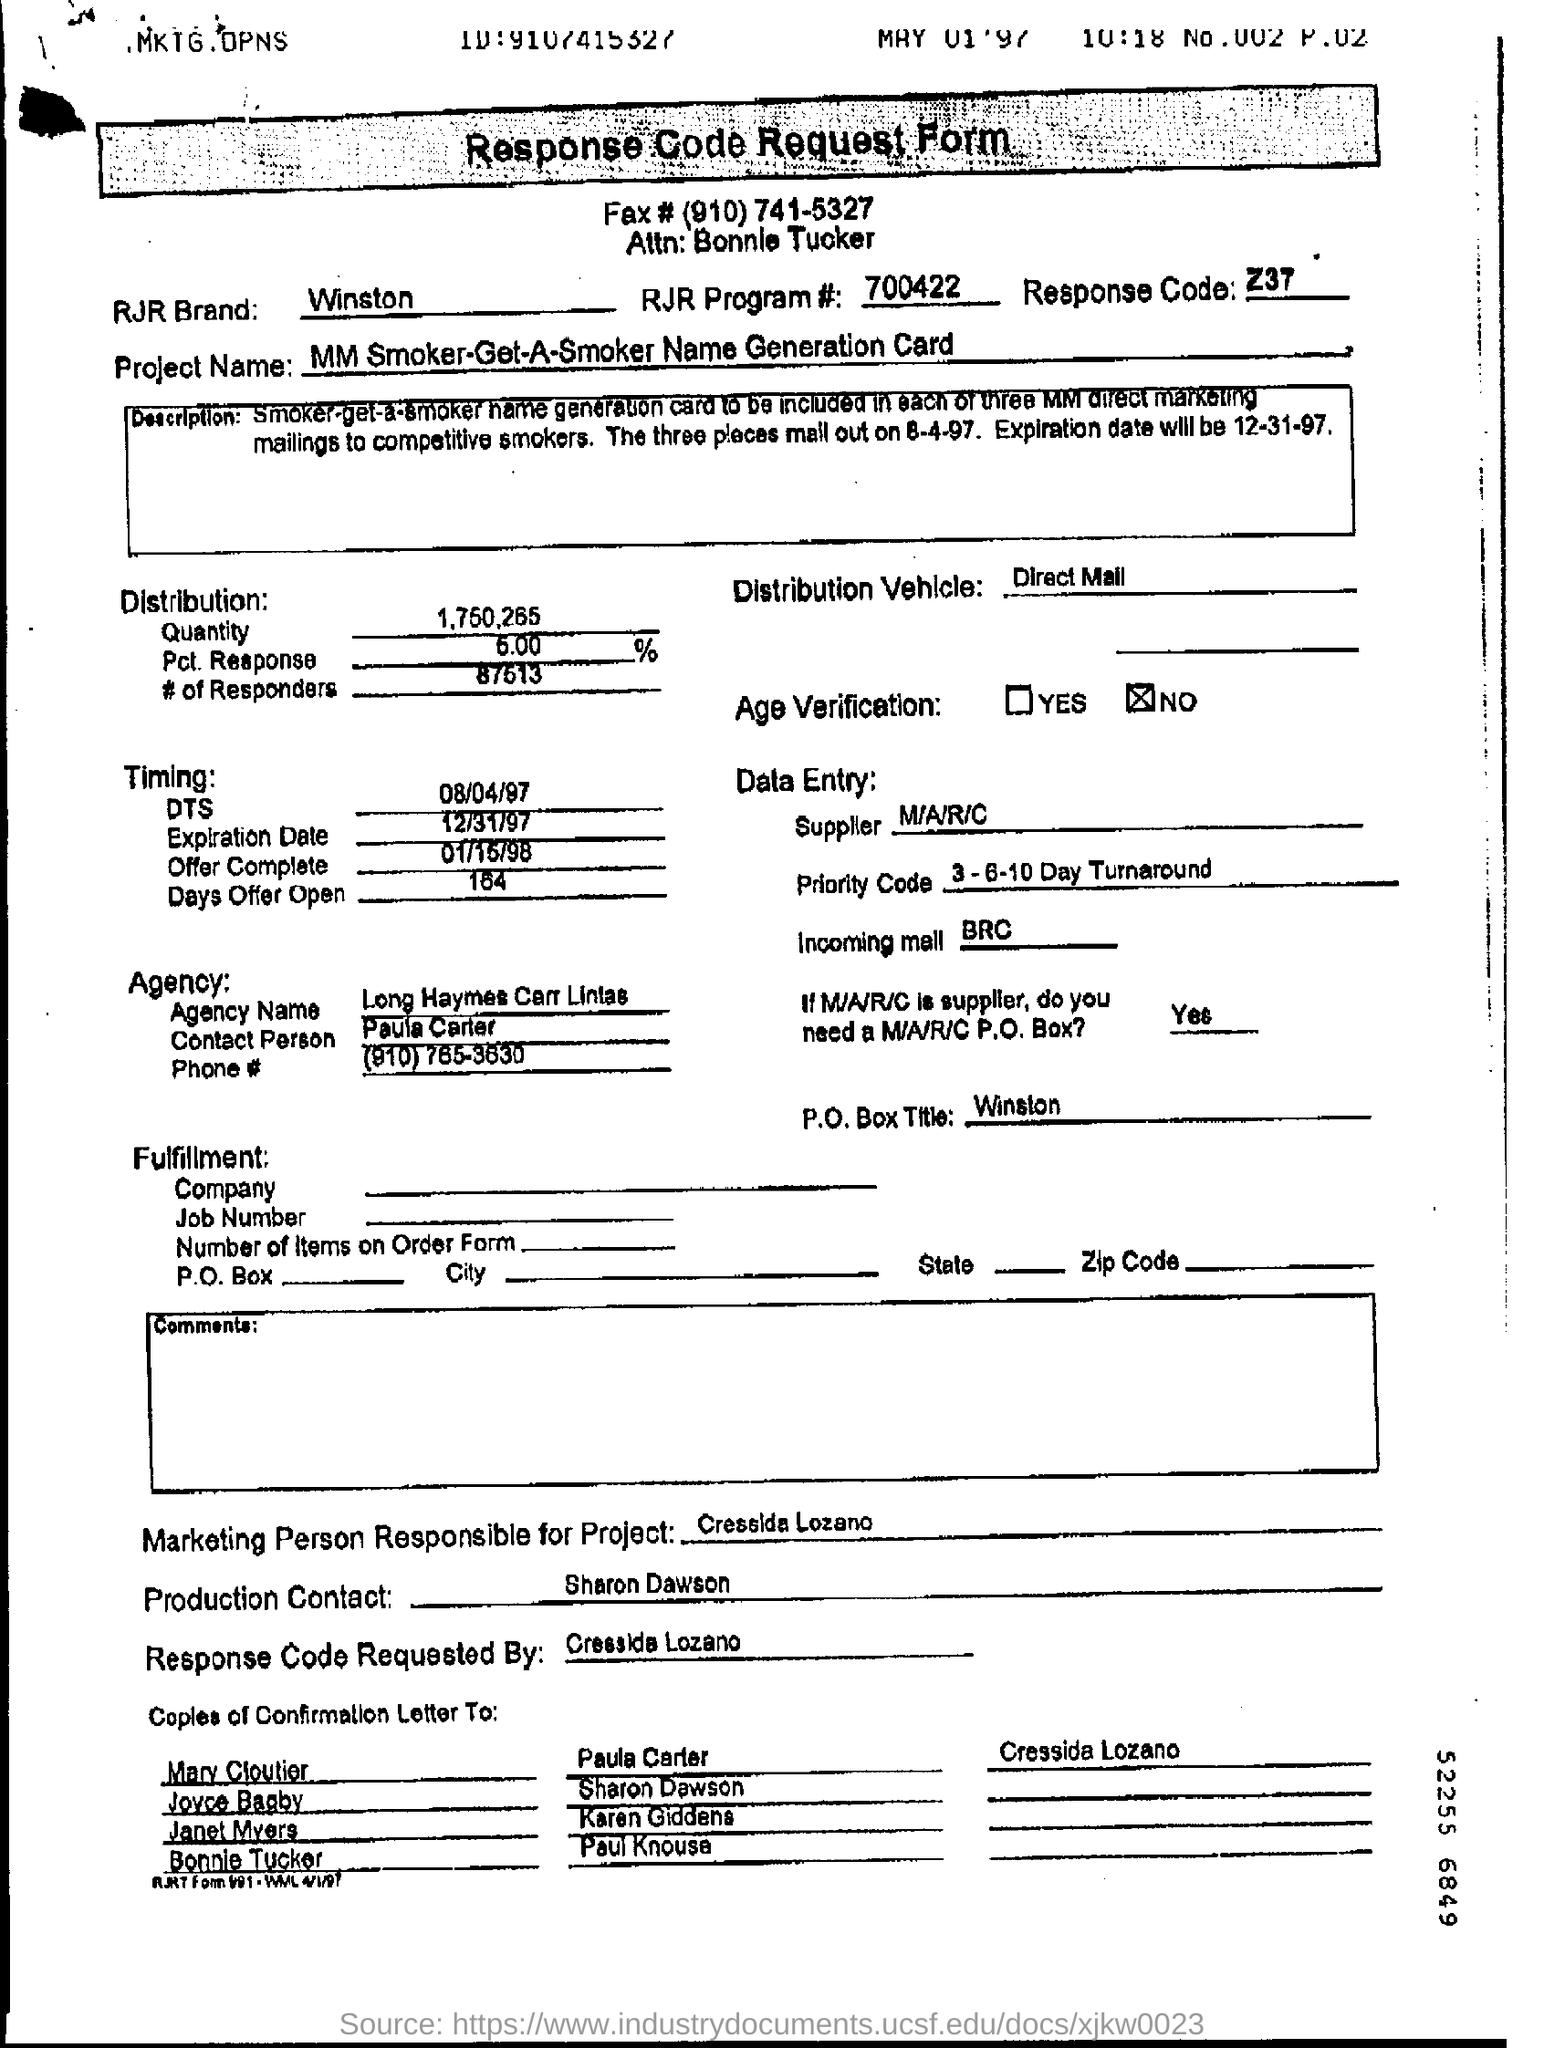What is the response code mentioned in the form?
Offer a very short reply. Z37. 